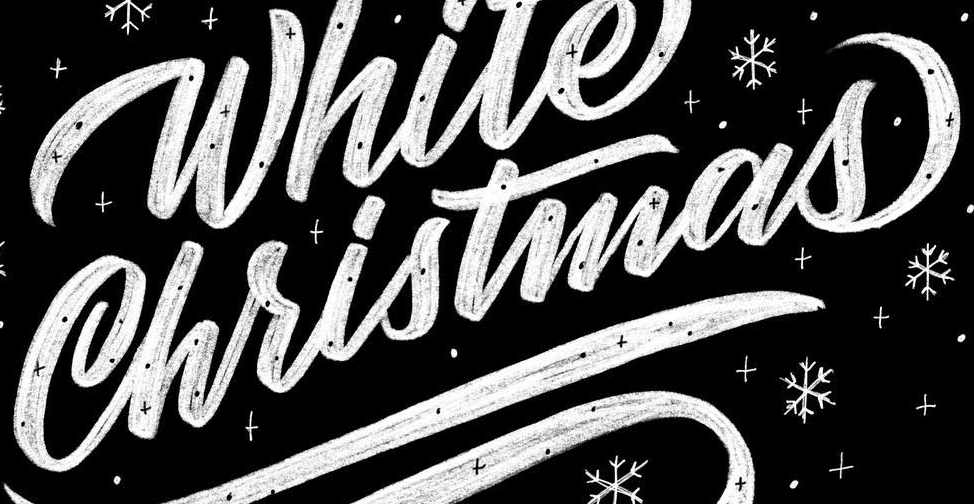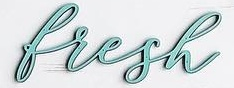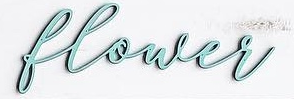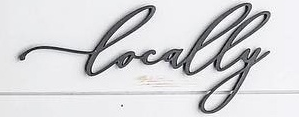Read the text content from these images in order, separated by a semicolon. Christmas; bresh; blower; Locally 